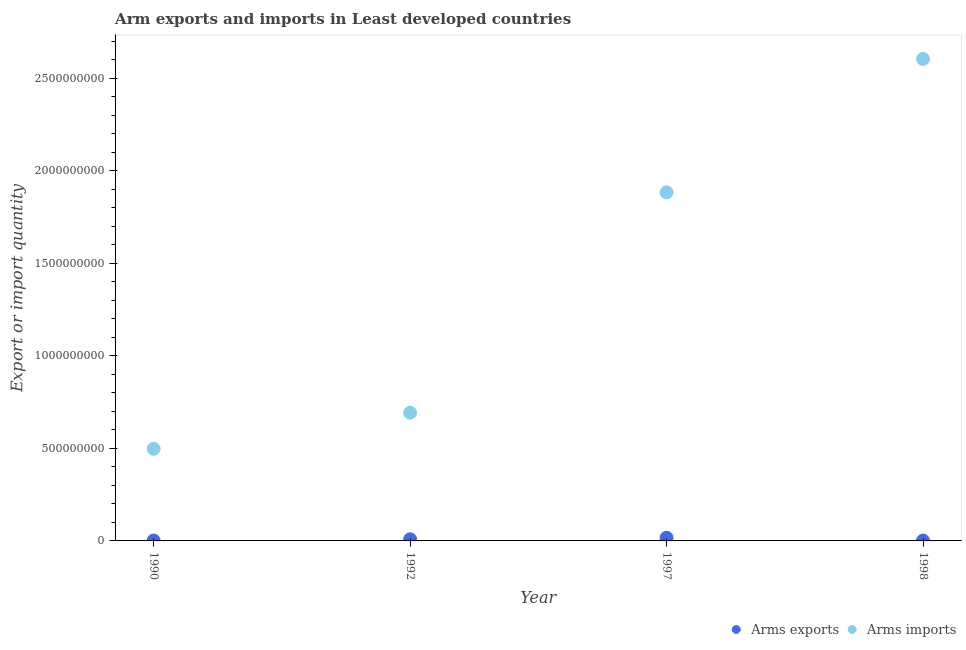How many different coloured dotlines are there?
Offer a very short reply. 2. Is the number of dotlines equal to the number of legend labels?
Give a very brief answer. Yes. What is the arms exports in 1998?
Your response must be concise. 2.00e+06. Across all years, what is the maximum arms imports?
Give a very brief answer. 2.60e+09. Across all years, what is the minimum arms imports?
Provide a succinct answer. 4.98e+08. In which year was the arms exports maximum?
Make the answer very short. 1997. In which year was the arms exports minimum?
Your answer should be very brief. 1990. What is the total arms imports in the graph?
Ensure brevity in your answer.  5.68e+09. What is the difference between the arms imports in 1992 and that in 1998?
Ensure brevity in your answer.  -1.91e+09. What is the difference between the arms exports in 1990 and the arms imports in 1992?
Give a very brief answer. -6.91e+08. What is the average arms exports per year?
Offer a very short reply. 7.50e+06. In the year 1992, what is the difference between the arms exports and arms imports?
Provide a succinct answer. -6.84e+08. In how many years, is the arms exports greater than 1700000000?
Provide a succinct answer. 0. What is the ratio of the arms exports in 1990 to that in 1992?
Make the answer very short. 0.22. What is the difference between the highest and the second highest arms exports?
Your answer should be very brief. 8.00e+06. What is the difference between the highest and the lowest arms imports?
Provide a short and direct response. 2.11e+09. Is the sum of the arms imports in 1990 and 1992 greater than the maximum arms exports across all years?
Provide a succinct answer. Yes. Does the arms exports monotonically increase over the years?
Provide a short and direct response. No. Is the arms imports strictly greater than the arms exports over the years?
Your answer should be very brief. Yes. How many years are there in the graph?
Your response must be concise. 4. What is the difference between two consecutive major ticks on the Y-axis?
Offer a terse response. 5.00e+08. Are the values on the major ticks of Y-axis written in scientific E-notation?
Ensure brevity in your answer.  No. Does the graph contain any zero values?
Provide a short and direct response. No. Where does the legend appear in the graph?
Provide a succinct answer. Bottom right. How many legend labels are there?
Offer a terse response. 2. What is the title of the graph?
Your answer should be compact. Arm exports and imports in Least developed countries. Does "Primary income" appear as one of the legend labels in the graph?
Your answer should be very brief. No. What is the label or title of the Y-axis?
Offer a terse response. Export or import quantity. What is the Export or import quantity in Arms imports in 1990?
Provide a succinct answer. 4.98e+08. What is the Export or import quantity in Arms exports in 1992?
Offer a terse response. 9.00e+06. What is the Export or import quantity of Arms imports in 1992?
Your response must be concise. 6.93e+08. What is the Export or import quantity of Arms exports in 1997?
Offer a terse response. 1.70e+07. What is the Export or import quantity of Arms imports in 1997?
Ensure brevity in your answer.  1.88e+09. What is the Export or import quantity of Arms exports in 1998?
Offer a very short reply. 2.00e+06. What is the Export or import quantity of Arms imports in 1998?
Ensure brevity in your answer.  2.60e+09. Across all years, what is the maximum Export or import quantity in Arms exports?
Your answer should be very brief. 1.70e+07. Across all years, what is the maximum Export or import quantity of Arms imports?
Ensure brevity in your answer.  2.60e+09. Across all years, what is the minimum Export or import quantity of Arms exports?
Offer a very short reply. 2.00e+06. Across all years, what is the minimum Export or import quantity in Arms imports?
Keep it short and to the point. 4.98e+08. What is the total Export or import quantity of Arms exports in the graph?
Provide a succinct answer. 3.00e+07. What is the total Export or import quantity in Arms imports in the graph?
Give a very brief answer. 5.68e+09. What is the difference between the Export or import quantity in Arms exports in 1990 and that in 1992?
Provide a succinct answer. -7.00e+06. What is the difference between the Export or import quantity of Arms imports in 1990 and that in 1992?
Provide a short and direct response. -1.95e+08. What is the difference between the Export or import quantity of Arms exports in 1990 and that in 1997?
Your answer should be very brief. -1.50e+07. What is the difference between the Export or import quantity in Arms imports in 1990 and that in 1997?
Make the answer very short. -1.39e+09. What is the difference between the Export or import quantity in Arms exports in 1990 and that in 1998?
Keep it short and to the point. 0. What is the difference between the Export or import quantity of Arms imports in 1990 and that in 1998?
Keep it short and to the point. -2.11e+09. What is the difference between the Export or import quantity in Arms exports in 1992 and that in 1997?
Keep it short and to the point. -8.00e+06. What is the difference between the Export or import quantity in Arms imports in 1992 and that in 1997?
Give a very brief answer. -1.19e+09. What is the difference between the Export or import quantity of Arms exports in 1992 and that in 1998?
Your answer should be very brief. 7.00e+06. What is the difference between the Export or import quantity of Arms imports in 1992 and that in 1998?
Offer a very short reply. -1.91e+09. What is the difference between the Export or import quantity in Arms exports in 1997 and that in 1998?
Provide a short and direct response. 1.50e+07. What is the difference between the Export or import quantity of Arms imports in 1997 and that in 1998?
Make the answer very short. -7.21e+08. What is the difference between the Export or import quantity of Arms exports in 1990 and the Export or import quantity of Arms imports in 1992?
Offer a very short reply. -6.91e+08. What is the difference between the Export or import quantity in Arms exports in 1990 and the Export or import quantity in Arms imports in 1997?
Offer a very short reply. -1.88e+09. What is the difference between the Export or import quantity in Arms exports in 1990 and the Export or import quantity in Arms imports in 1998?
Ensure brevity in your answer.  -2.60e+09. What is the difference between the Export or import quantity in Arms exports in 1992 and the Export or import quantity in Arms imports in 1997?
Give a very brief answer. -1.88e+09. What is the difference between the Export or import quantity of Arms exports in 1992 and the Export or import quantity of Arms imports in 1998?
Provide a succinct answer. -2.60e+09. What is the difference between the Export or import quantity of Arms exports in 1997 and the Export or import quantity of Arms imports in 1998?
Your response must be concise. -2.59e+09. What is the average Export or import quantity in Arms exports per year?
Your answer should be very brief. 7.50e+06. What is the average Export or import quantity in Arms imports per year?
Provide a short and direct response. 1.42e+09. In the year 1990, what is the difference between the Export or import quantity of Arms exports and Export or import quantity of Arms imports?
Keep it short and to the point. -4.96e+08. In the year 1992, what is the difference between the Export or import quantity in Arms exports and Export or import quantity in Arms imports?
Offer a very short reply. -6.84e+08. In the year 1997, what is the difference between the Export or import quantity of Arms exports and Export or import quantity of Arms imports?
Provide a succinct answer. -1.87e+09. In the year 1998, what is the difference between the Export or import quantity in Arms exports and Export or import quantity in Arms imports?
Keep it short and to the point. -2.60e+09. What is the ratio of the Export or import quantity in Arms exports in 1990 to that in 1992?
Make the answer very short. 0.22. What is the ratio of the Export or import quantity of Arms imports in 1990 to that in 1992?
Offer a very short reply. 0.72. What is the ratio of the Export or import quantity of Arms exports in 1990 to that in 1997?
Give a very brief answer. 0.12. What is the ratio of the Export or import quantity of Arms imports in 1990 to that in 1997?
Your response must be concise. 0.26. What is the ratio of the Export or import quantity of Arms exports in 1990 to that in 1998?
Provide a short and direct response. 1. What is the ratio of the Export or import quantity in Arms imports in 1990 to that in 1998?
Provide a short and direct response. 0.19. What is the ratio of the Export or import quantity of Arms exports in 1992 to that in 1997?
Offer a very short reply. 0.53. What is the ratio of the Export or import quantity of Arms imports in 1992 to that in 1997?
Your response must be concise. 0.37. What is the ratio of the Export or import quantity of Arms exports in 1992 to that in 1998?
Offer a very short reply. 4.5. What is the ratio of the Export or import quantity in Arms imports in 1992 to that in 1998?
Offer a very short reply. 0.27. What is the ratio of the Export or import quantity of Arms imports in 1997 to that in 1998?
Your answer should be compact. 0.72. What is the difference between the highest and the second highest Export or import quantity of Arms imports?
Make the answer very short. 7.21e+08. What is the difference between the highest and the lowest Export or import quantity of Arms exports?
Make the answer very short. 1.50e+07. What is the difference between the highest and the lowest Export or import quantity in Arms imports?
Give a very brief answer. 2.11e+09. 